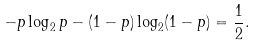Convert formula to latex. <formula><loc_0><loc_0><loc_500><loc_500>- p \log _ { 2 } p - ( 1 - p ) \log _ { 2 } ( 1 - p ) = \frac { 1 } { 2 } .</formula> 